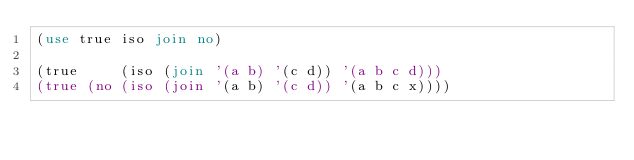<code> <loc_0><loc_0><loc_500><loc_500><_Perl_>(use true iso join no)

(true     (iso (join '(a b) '(c d)) '(a b c d)))
(true (no (iso (join '(a b) '(c d)) '(a b c x))))
</code> 